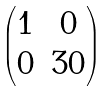<formula> <loc_0><loc_0><loc_500><loc_500>\begin{pmatrix} 1 & 0 \\ 0 & 3 0 \end{pmatrix}</formula> 